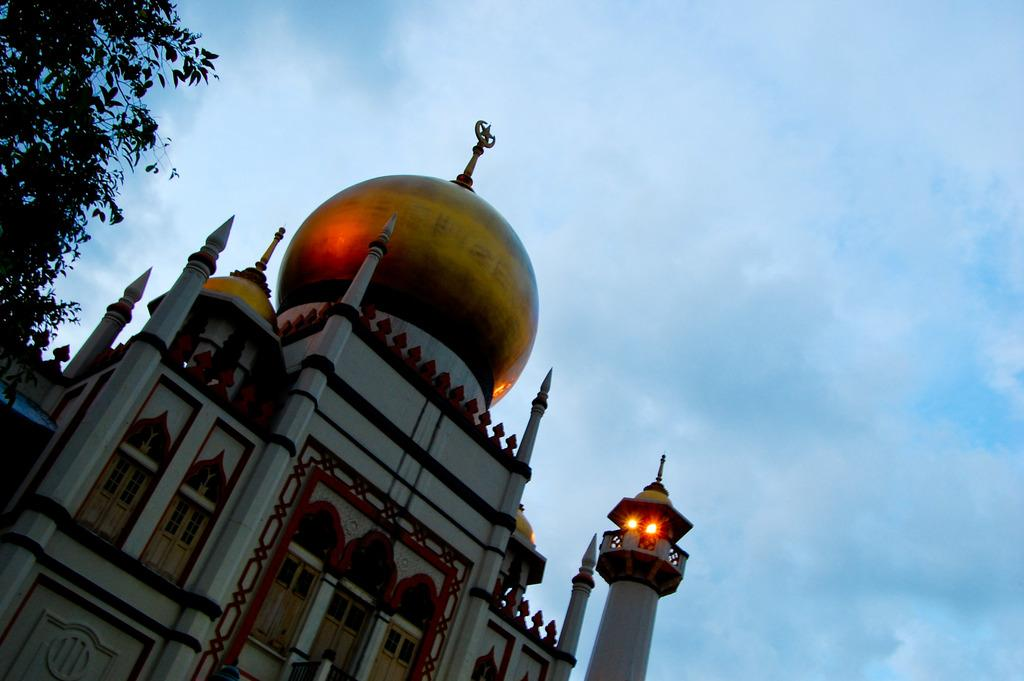What type of building is in the image? There is a mosque in the image. What colors are used for the mosque? The mosque is in white and gold color. What can be seen in the top left corner of the image? There is a tree in the left top of the image. What is visible in the background of the image? The sky is visible in the background of the image. How many fowls are perched on the rail in the image? There are no fowls or rails present in the image. What type of leaf is falling from the tree in the image? There is no leaf falling from the tree in the image; it is a static image. 